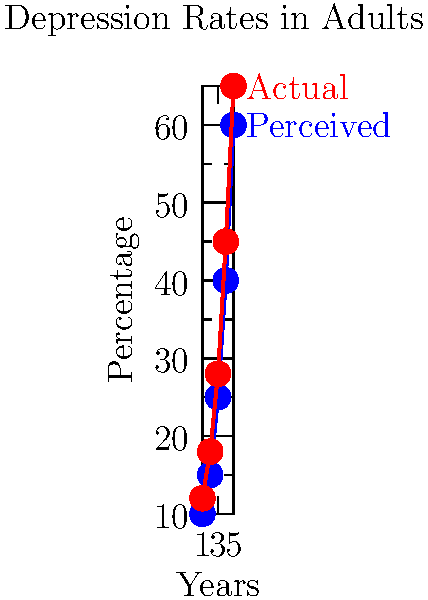The graph shows the perceived and actual rates of depression in adults over 5 years. What misconception about mental health statistics does this visualization reveal, and how might this impact public understanding and empathy towards mental health issues? To identify the misconception and its impact, let's analyze the graph step-by-step:

1. Data representation:
   - Blue line: Perceived depression rates
   - Red line: Actual depression rates

2. Trend analysis:
   - Both perceived and actual rates increase over time
   - Actual rates are consistently higher than perceived rates

3. Identifying the misconception:
   - The graph shows that people underestimate the prevalence of depression
   - This underestimation is consistent across all five years

4. Quantifying the misconception:
   - The gap between perceived and actual rates increases over time
   - By year 5, the perceived rate is 60% while the actual rate is 65%

5. Impact on public understanding:
   - Underestimation may lead to a lack of awareness about the true scale of depression
   - This could result in insufficient resources allocated to mental health services

6. Impact on empathy:
   - People might underestimate the likelihood of encountering someone with depression
   - This could lead to less empathy or support for those struggling with mental health issues

7. Implications for mental health advocacy:
   - Highlights the need for better education about the prevalence of depression
   - Emphasizes the importance of accurate data dissemination to the public

The misconception revealed is the consistent underestimation of depression rates in adults. This can lead to reduced public awareness, inadequate resource allocation, and potentially less empathy towards those affected by depression.
Answer: Underestimation of depression prevalence, leading to reduced awareness and potential lack of empathy 